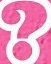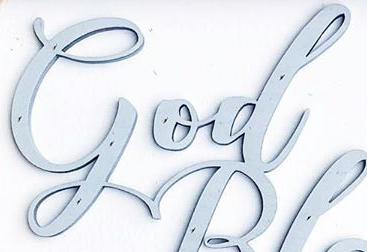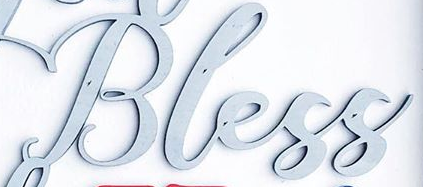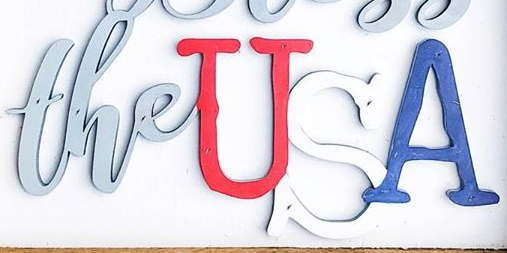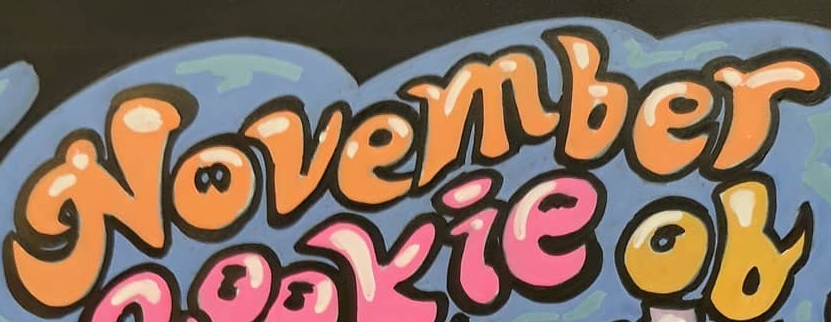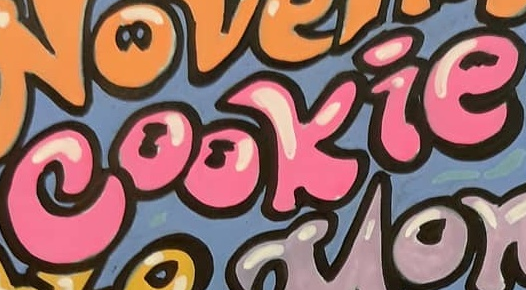What words are shown in these images in order, separated by a semicolon? ?; God; Bless; theUSA; November; cookie 